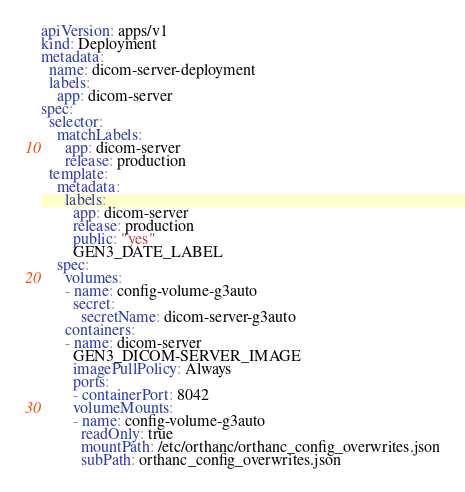<code> <loc_0><loc_0><loc_500><loc_500><_YAML_>apiVersion: apps/v1
kind: Deployment
metadata:
  name: dicom-server-deployment
  labels:
    app: dicom-server
spec:
  selector:
    matchLabels:
      app: dicom-server
      release: production
  template:
    metadata:
      labels:
        app: dicom-server
        release: production
        public: "yes"
        GEN3_DATE_LABEL
    spec:
      volumes:
      - name: config-volume-g3auto
        secret:
          secretName: dicom-server-g3auto
      containers:
      - name: dicom-server
        GEN3_DICOM-SERVER_IMAGE
        imagePullPolicy: Always
        ports:
        - containerPort: 8042
        volumeMounts:
        - name: config-volume-g3auto
          readOnly: true
          mountPath: /etc/orthanc/orthanc_config_overwrites.json
          subPath: orthanc_config_overwrites.json
</code> 